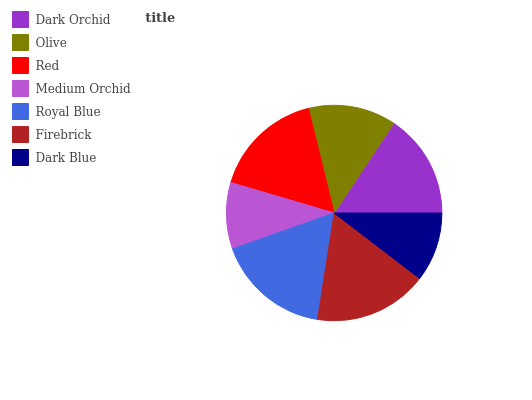Is Medium Orchid the minimum?
Answer yes or no. Yes. Is Royal Blue the maximum?
Answer yes or no. Yes. Is Olive the minimum?
Answer yes or no. No. Is Olive the maximum?
Answer yes or no. No. Is Dark Orchid greater than Olive?
Answer yes or no. Yes. Is Olive less than Dark Orchid?
Answer yes or no. Yes. Is Olive greater than Dark Orchid?
Answer yes or no. No. Is Dark Orchid less than Olive?
Answer yes or no. No. Is Dark Orchid the high median?
Answer yes or no. Yes. Is Dark Orchid the low median?
Answer yes or no. Yes. Is Dark Blue the high median?
Answer yes or no. No. Is Olive the low median?
Answer yes or no. No. 